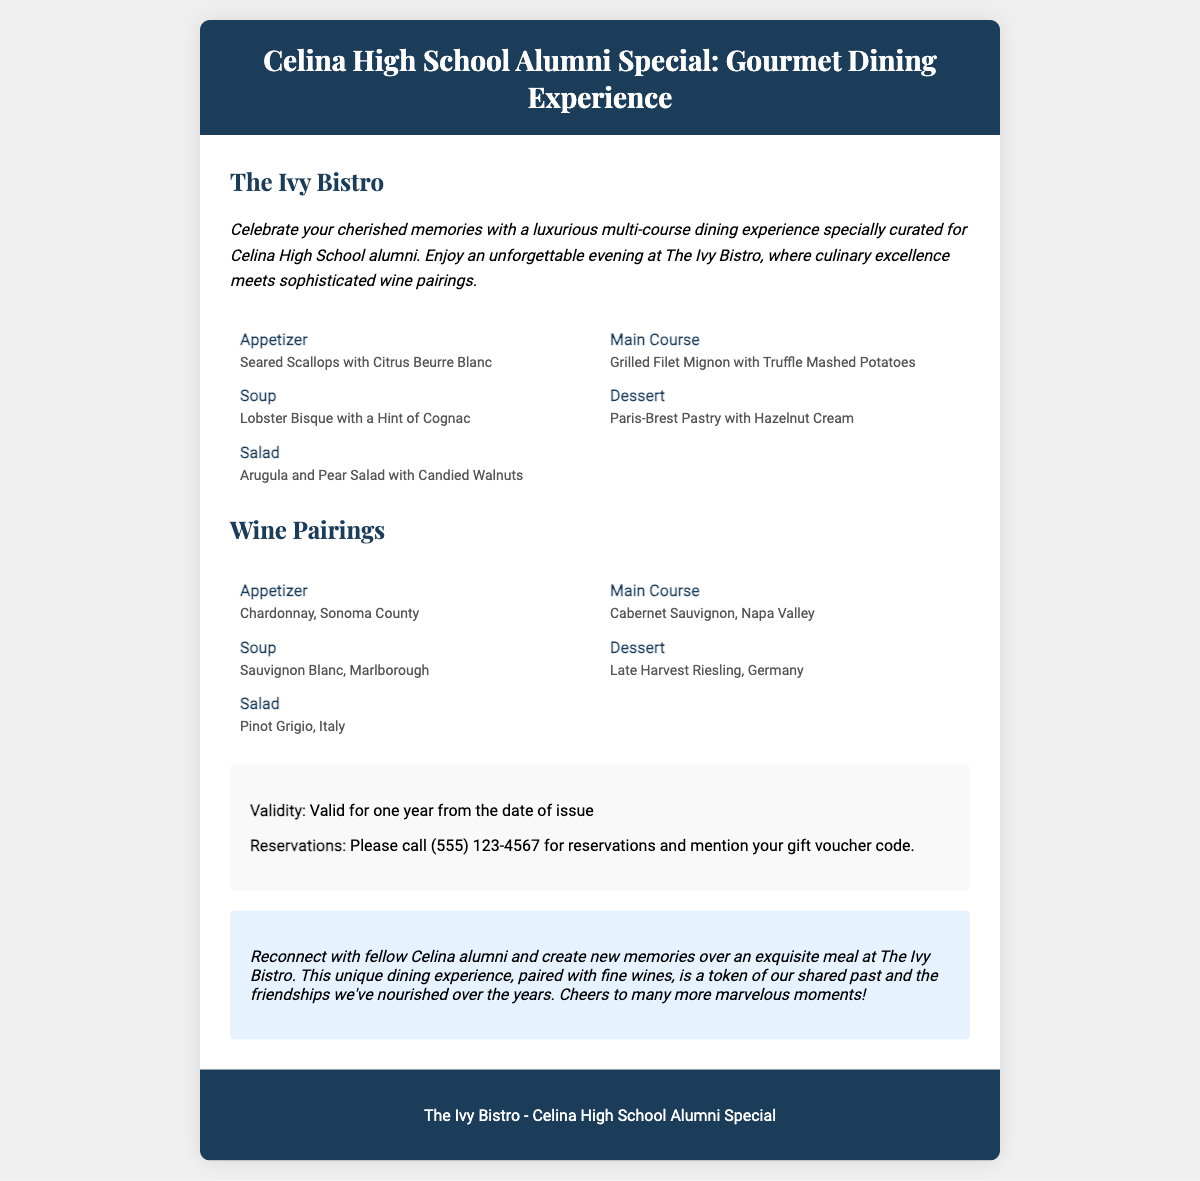What is the name of the restaurant? The restaurant is mentioned in the header of the document, which is The Ivy Bistro.
Answer: The Ivy Bistro How many courses are included in the dining experience? The document lists five courses (appetizer, soup, salad, main course, dessert), which are part of a multi-course meal.
Answer: Five What wine is paired with the appetizer? The wine pairing for the appetizer is specified under the wine pairings section, which is Chardonnay, Sonoma County.
Answer: Chardonnay, Sonoma County What is the validity period of the gift voucher? The validity period is stated in the details section, which mentions one year from the date of issue.
Answer: One year What should you do to make a reservation? The document outlines that you should call a specific phone number to make a reservation.
Answer: Call (555) 123-4567 What type of experience does the voucher offer? The document emphasizes that the dining experience is luxurious, specifically targeting alumni memories.
Answer: Luxurious dining experience What is mentioned in the personal message section? The personal message highlights rekindling memories with fellow alumni over a meal, illustrated in the content.
Answer: Create new memories What two ingredients are in the Lobster Bisque? The soup's composition includes lobster and cognac, which can be found in the description of the soup.
Answer: Lobster, cognac What is one of the dessert options? The dessert options are listed in the menu section, one being Paris-Brest Pastry with Hazelnut Cream.
Answer: Paris-Brest Pastry with Hazelnut Cream 